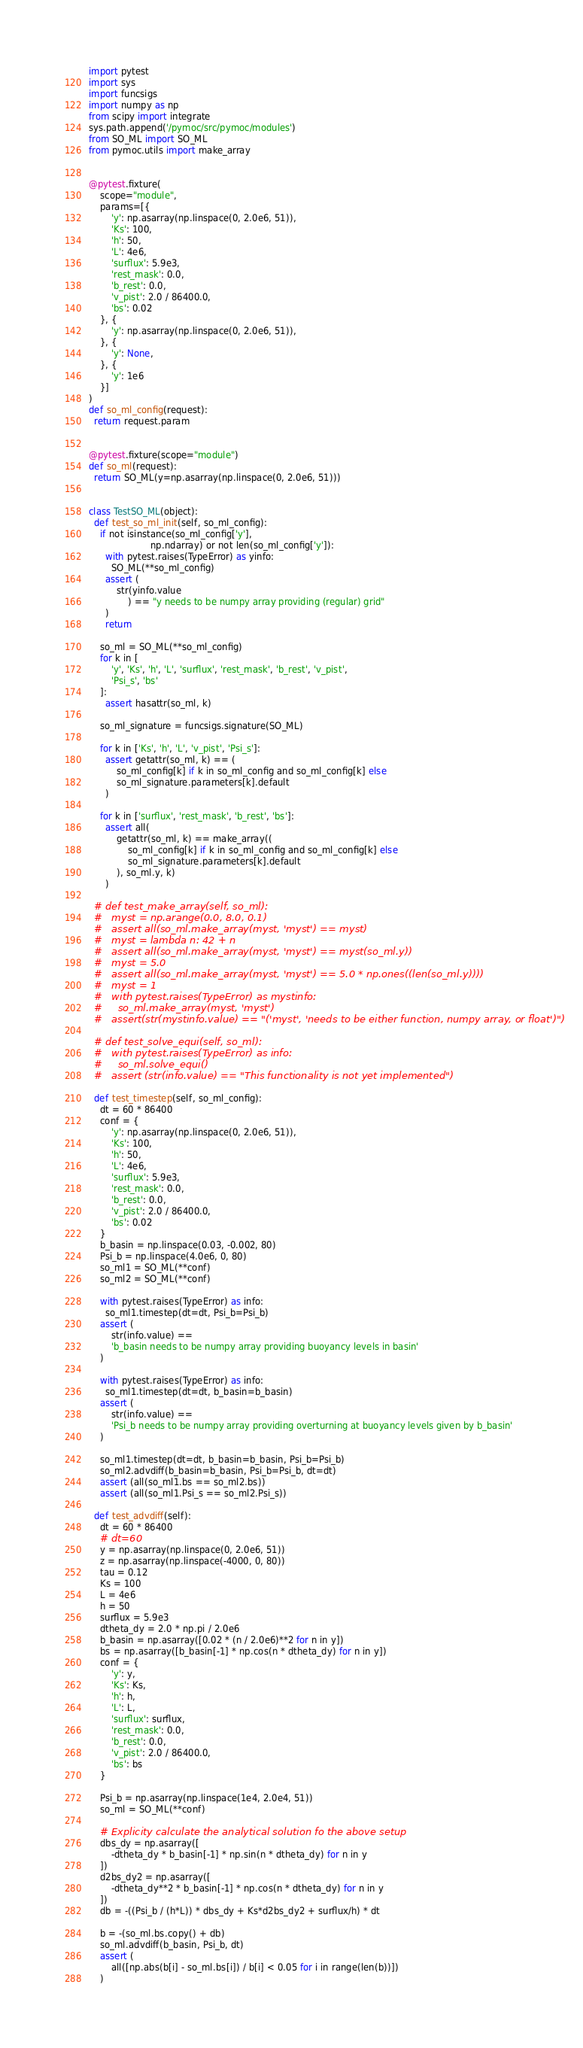Convert code to text. <code><loc_0><loc_0><loc_500><loc_500><_Python_>import pytest
import sys
import funcsigs
import numpy as np
from scipy import integrate
sys.path.append('/pymoc/src/pymoc/modules')
from SO_ML import SO_ML
from pymoc.utils import make_array


@pytest.fixture(
    scope="module",
    params=[{
        'y': np.asarray(np.linspace(0, 2.0e6, 51)),
        'Ks': 100,
        'h': 50,
        'L': 4e6,
        'surflux': 5.9e3,
        'rest_mask': 0.0,
        'b_rest': 0.0,
        'v_pist': 2.0 / 86400.0,
        'bs': 0.02
    }, {
        'y': np.asarray(np.linspace(0, 2.0e6, 51)),
    }, {
        'y': None,
    }, {
        'y': 1e6
    }]
)
def so_ml_config(request):
  return request.param


@pytest.fixture(scope="module")
def so_ml(request):
  return SO_ML(y=np.asarray(np.linspace(0, 2.0e6, 51)))


class TestSO_ML(object):
  def test_so_ml_init(self, so_ml_config):
    if not isinstance(so_ml_config['y'],
                      np.ndarray) or not len(so_ml_config['y']):
      with pytest.raises(TypeError) as yinfo:
        SO_ML(**so_ml_config)
      assert (
          str(yinfo.value
              ) == "y needs to be numpy array providing (regular) grid"
      )
      return

    so_ml = SO_ML(**so_ml_config)
    for k in [
        'y', 'Ks', 'h', 'L', 'surflux', 'rest_mask', 'b_rest', 'v_pist',
        'Psi_s', 'bs'
    ]:
      assert hasattr(so_ml, k)

    so_ml_signature = funcsigs.signature(SO_ML)

    for k in ['Ks', 'h', 'L', 'v_pist', 'Psi_s']:
      assert getattr(so_ml, k) == (
          so_ml_config[k] if k in so_ml_config and so_ml_config[k] else
          so_ml_signature.parameters[k].default
      )

    for k in ['surflux', 'rest_mask', 'b_rest', 'bs']:
      assert all(
          getattr(so_ml, k) == make_array((
              so_ml_config[k] if k in so_ml_config and so_ml_config[k] else
              so_ml_signature.parameters[k].default
          ), so_ml.y, k)
      )

  # def test_make_array(self, so_ml):
  #   myst = np.arange(0.0, 8.0, 0.1)
  #   assert all(so_ml.make_array(myst, 'myst') == myst)
  #   myst = lambda n: 42 + n
  #   assert all(so_ml.make_array(myst, 'myst') == myst(so_ml.y))
  #   myst = 5.0
  #   assert all(so_ml.make_array(myst, 'myst') == 5.0 * np.ones((len(so_ml.y))))
  #   myst = 1
  #   with pytest.raises(TypeError) as mystinfo:
  #     so_ml.make_array(myst, 'myst')
  #   assert(str(mystinfo.value) == "('myst', 'needs to be either function, numpy array, or float')")

  # def test_solve_equi(self, so_ml):
  #   with pytest.raises(TypeError) as info:
  #     so_ml.solve_equi()
  #   assert (str(info.value) == "This functionality is not yet implemented")

  def test_timestep(self, so_ml_config):
    dt = 60 * 86400
    conf = {
        'y': np.asarray(np.linspace(0, 2.0e6, 51)),
        'Ks': 100,
        'h': 50,
        'L': 4e6,
        'surflux': 5.9e3,
        'rest_mask': 0.0,
        'b_rest': 0.0,
        'v_pist': 2.0 / 86400.0,
        'bs': 0.02
    }
    b_basin = np.linspace(0.03, -0.002, 80)
    Psi_b = np.linspace(4.0e6, 0, 80)
    so_ml1 = SO_ML(**conf)
    so_ml2 = SO_ML(**conf)

    with pytest.raises(TypeError) as info:
      so_ml1.timestep(dt=dt, Psi_b=Psi_b)
    assert (
        str(info.value) ==
        'b_basin needs to be numpy array providing buoyancy levels in basin'
    )

    with pytest.raises(TypeError) as info:
      so_ml1.timestep(dt=dt, b_basin=b_basin)
    assert (
        str(info.value) ==
        'Psi_b needs to be numpy array providing overturning at buoyancy levels given by b_basin'
    )

    so_ml1.timestep(dt=dt, b_basin=b_basin, Psi_b=Psi_b)
    so_ml2.advdiff(b_basin=b_basin, Psi_b=Psi_b, dt=dt)
    assert (all(so_ml1.bs == so_ml2.bs))
    assert (all(so_ml1.Psi_s == so_ml2.Psi_s))

  def test_advdiff(self):
    dt = 60 * 86400
    # dt=60
    y = np.asarray(np.linspace(0, 2.0e6, 51))
    z = np.asarray(np.linspace(-4000, 0, 80))
    tau = 0.12
    Ks = 100
    L = 4e6
    h = 50
    surflux = 5.9e3
    dtheta_dy = 2.0 * np.pi / 2.0e6
    b_basin = np.asarray([0.02 * (n / 2.0e6)**2 for n in y])
    bs = np.asarray([b_basin[-1] * np.cos(n * dtheta_dy) for n in y])
    conf = {
        'y': y,
        'Ks': Ks,
        'h': h,
        'L': L,
        'surflux': surflux,
        'rest_mask': 0.0,
        'b_rest': 0.0,
        'v_pist': 2.0 / 86400.0,
        'bs': bs
    }

    Psi_b = np.asarray(np.linspace(1e4, 2.0e4, 51))
    so_ml = SO_ML(**conf)

    # Explicity calculate the analytical solution fo the above setup
    dbs_dy = np.asarray([
        -dtheta_dy * b_basin[-1] * np.sin(n * dtheta_dy) for n in y
    ])
    d2bs_dy2 = np.asarray([
        -dtheta_dy**2 * b_basin[-1] * np.cos(n * dtheta_dy) for n in y
    ])
    db = -((Psi_b / (h*L)) * dbs_dy + Ks*d2bs_dy2 + surflux/h) * dt

    b = -(so_ml.bs.copy() + db)
    so_ml.advdiff(b_basin, Psi_b, dt)
    assert (
        all([np.abs(b[i] - so_ml.bs[i]) / b[i] < 0.05 for i in range(len(b))])
    )
</code> 